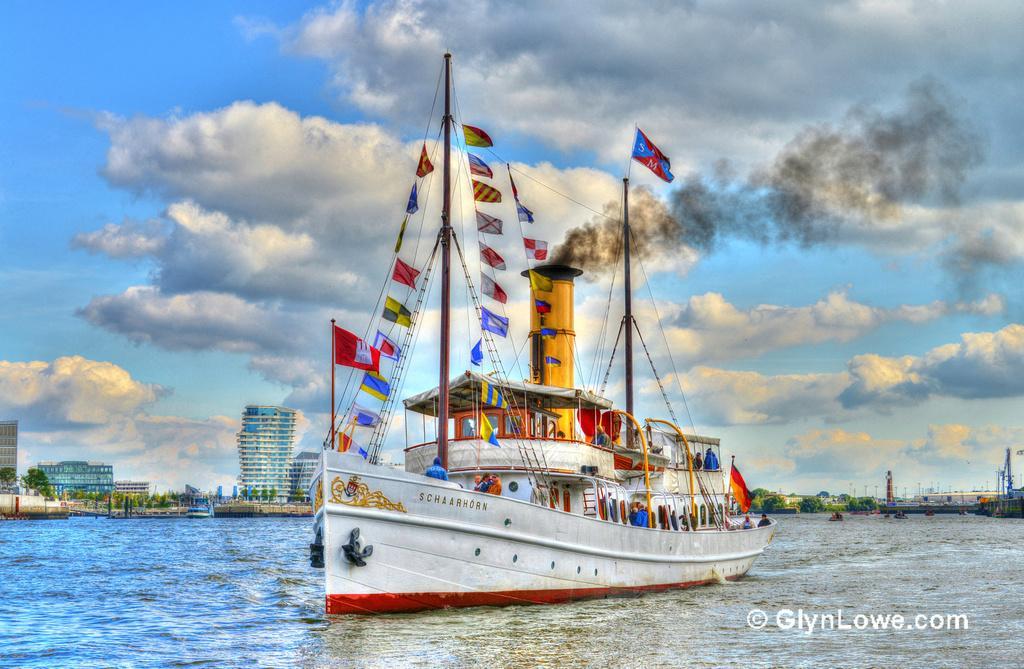Describe this image in one or two sentences. It is an edited image there is a ship sailing on the water and behind the ship there are some buildings and trees. 